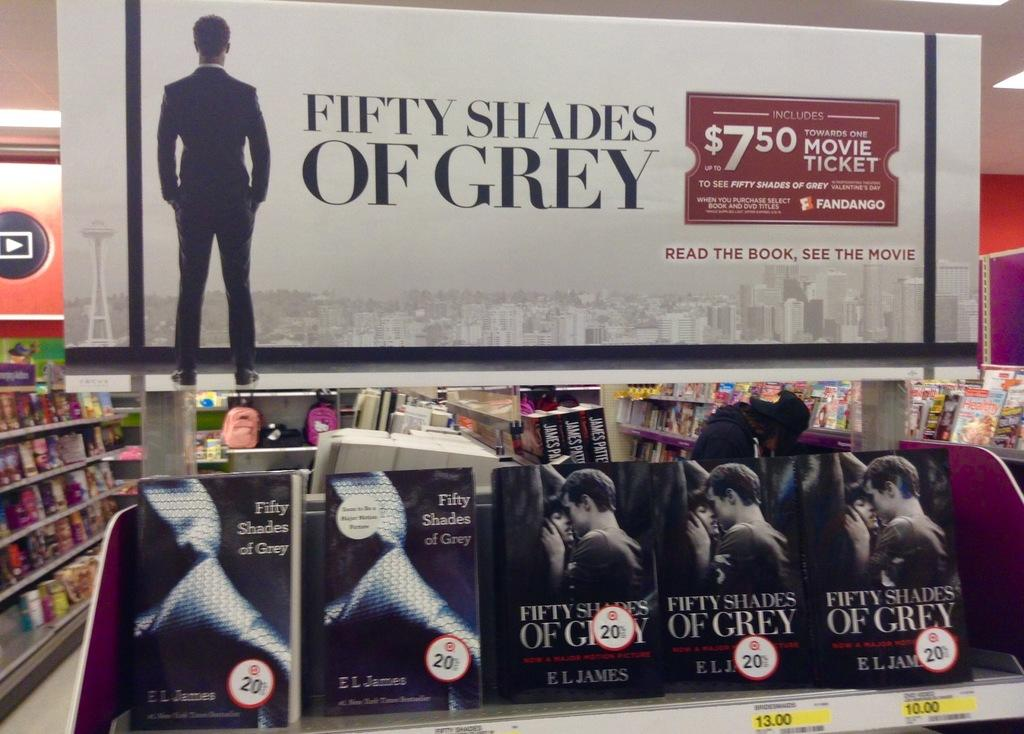Provide a one-sentence caption for the provided image. Fifty Shades of Grey movies for sale inside a store. 